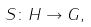Convert formula to latex. <formula><loc_0><loc_0><loc_500><loc_500>S \colon H \rightarrow G ,</formula> 